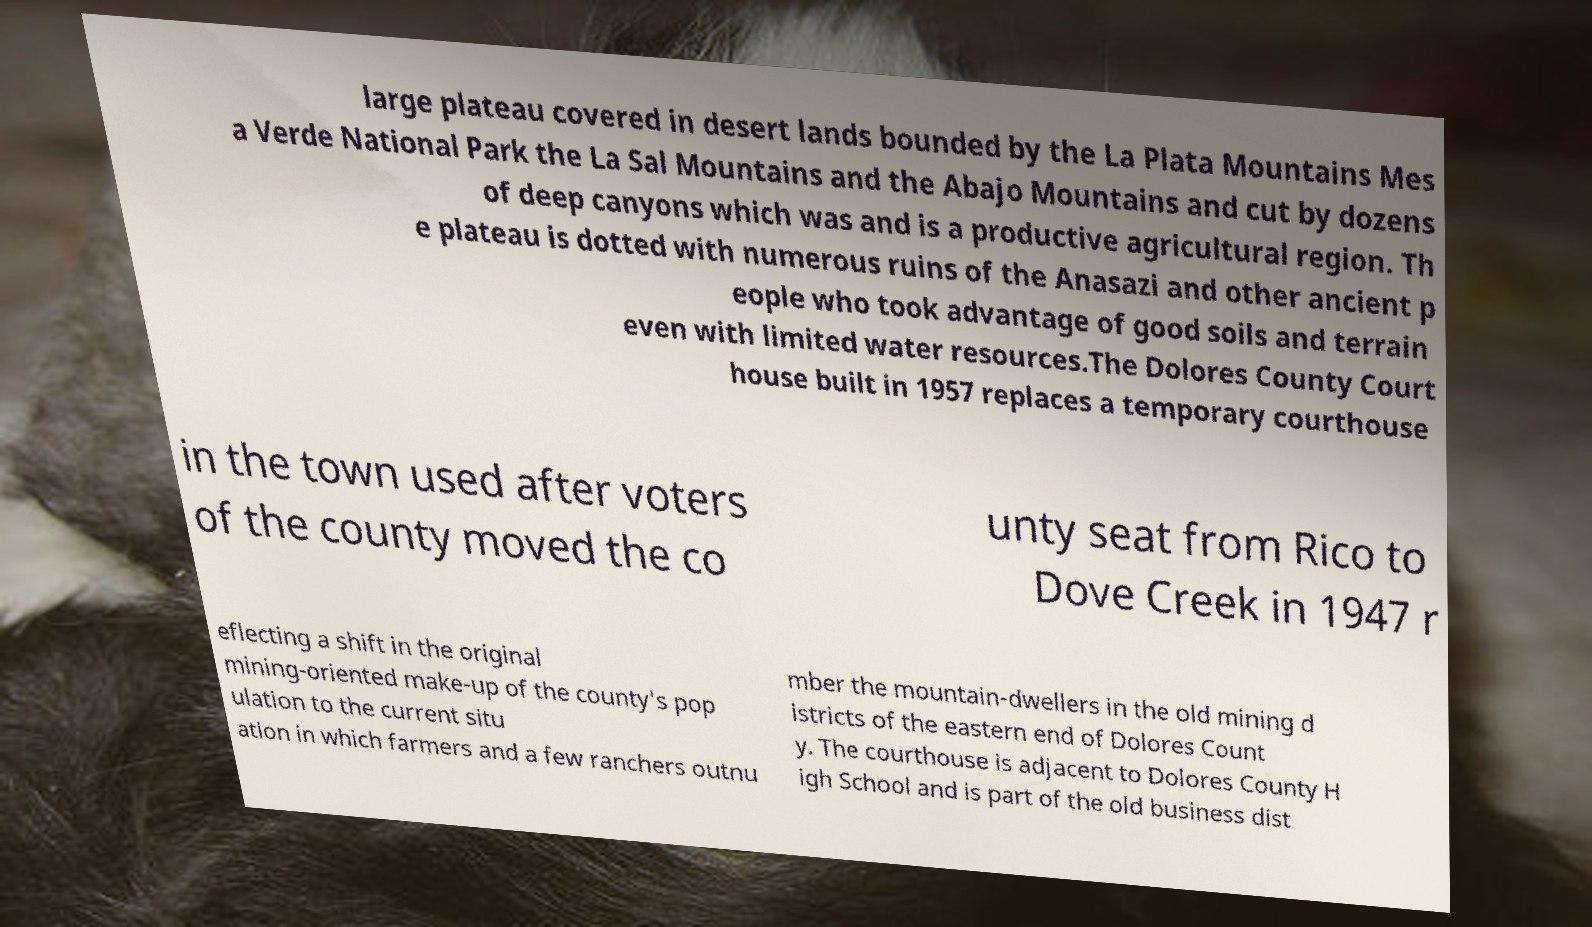Please identify and transcribe the text found in this image. large plateau covered in desert lands bounded by the La Plata Mountains Mes a Verde National Park the La Sal Mountains and the Abajo Mountains and cut by dozens of deep canyons which was and is a productive agricultural region. Th e plateau is dotted with numerous ruins of the Anasazi and other ancient p eople who took advantage of good soils and terrain even with limited water resources.The Dolores County Court house built in 1957 replaces a temporary courthouse in the town used after voters of the county moved the co unty seat from Rico to Dove Creek in 1947 r eflecting a shift in the original mining-oriented make-up of the county's pop ulation to the current situ ation in which farmers and a few ranchers outnu mber the mountain-dwellers in the old mining d istricts of the eastern end of Dolores Count y. The courthouse is adjacent to Dolores County H igh School and is part of the old business dist 